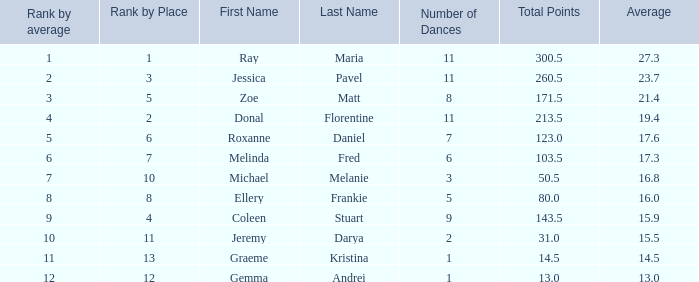If your rank by average is 9, what is the name of the couple? Coleen & Stuart. 